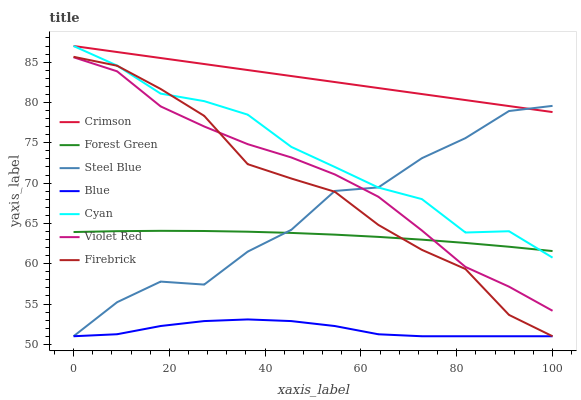Does Blue have the minimum area under the curve?
Answer yes or no. Yes. Does Crimson have the maximum area under the curve?
Answer yes or no. Yes. Does Violet Red have the minimum area under the curve?
Answer yes or no. No. Does Violet Red have the maximum area under the curve?
Answer yes or no. No. Is Crimson the smoothest?
Answer yes or no. Yes. Is Steel Blue the roughest?
Answer yes or no. Yes. Is Violet Red the smoothest?
Answer yes or no. No. Is Violet Red the roughest?
Answer yes or no. No. Does Blue have the lowest value?
Answer yes or no. Yes. Does Violet Red have the lowest value?
Answer yes or no. No. Does Cyan have the highest value?
Answer yes or no. Yes. Does Violet Red have the highest value?
Answer yes or no. No. Is Blue less than Violet Red?
Answer yes or no. Yes. Is Cyan greater than Violet Red?
Answer yes or no. Yes. Does Blue intersect Steel Blue?
Answer yes or no. Yes. Is Blue less than Steel Blue?
Answer yes or no. No. Is Blue greater than Steel Blue?
Answer yes or no. No. Does Blue intersect Violet Red?
Answer yes or no. No. 